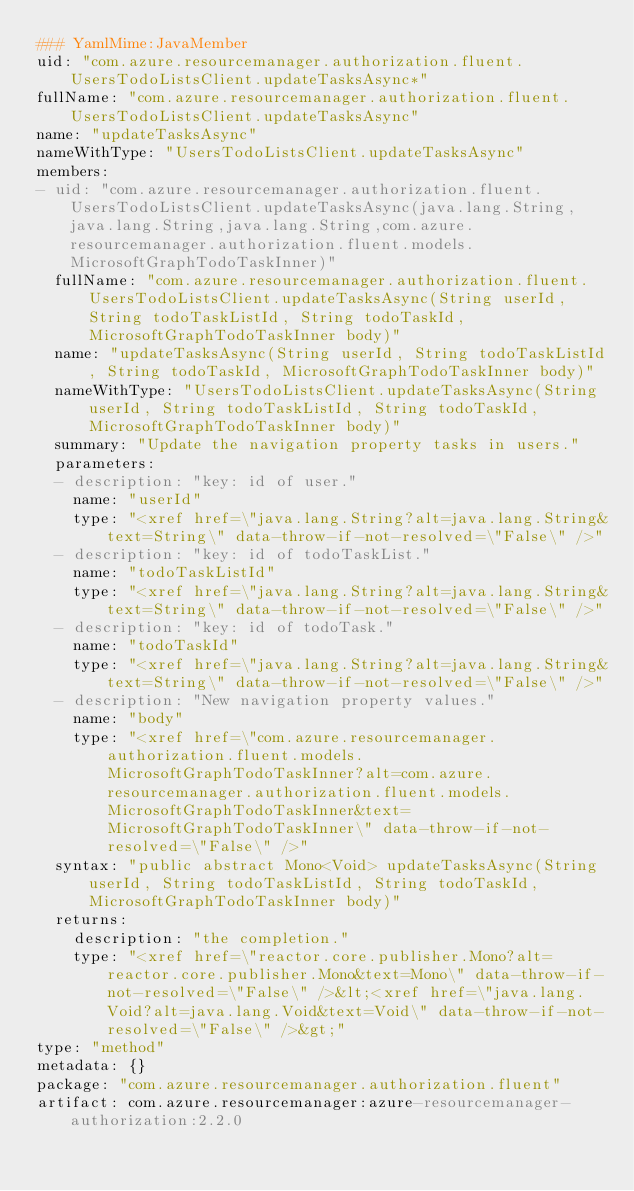<code> <loc_0><loc_0><loc_500><loc_500><_YAML_>### YamlMime:JavaMember
uid: "com.azure.resourcemanager.authorization.fluent.UsersTodoListsClient.updateTasksAsync*"
fullName: "com.azure.resourcemanager.authorization.fluent.UsersTodoListsClient.updateTasksAsync"
name: "updateTasksAsync"
nameWithType: "UsersTodoListsClient.updateTasksAsync"
members:
- uid: "com.azure.resourcemanager.authorization.fluent.UsersTodoListsClient.updateTasksAsync(java.lang.String,java.lang.String,java.lang.String,com.azure.resourcemanager.authorization.fluent.models.MicrosoftGraphTodoTaskInner)"
  fullName: "com.azure.resourcemanager.authorization.fluent.UsersTodoListsClient.updateTasksAsync(String userId, String todoTaskListId, String todoTaskId, MicrosoftGraphTodoTaskInner body)"
  name: "updateTasksAsync(String userId, String todoTaskListId, String todoTaskId, MicrosoftGraphTodoTaskInner body)"
  nameWithType: "UsersTodoListsClient.updateTasksAsync(String userId, String todoTaskListId, String todoTaskId, MicrosoftGraphTodoTaskInner body)"
  summary: "Update the navigation property tasks in users."
  parameters:
  - description: "key: id of user."
    name: "userId"
    type: "<xref href=\"java.lang.String?alt=java.lang.String&text=String\" data-throw-if-not-resolved=\"False\" />"
  - description: "key: id of todoTaskList."
    name: "todoTaskListId"
    type: "<xref href=\"java.lang.String?alt=java.lang.String&text=String\" data-throw-if-not-resolved=\"False\" />"
  - description: "key: id of todoTask."
    name: "todoTaskId"
    type: "<xref href=\"java.lang.String?alt=java.lang.String&text=String\" data-throw-if-not-resolved=\"False\" />"
  - description: "New navigation property values."
    name: "body"
    type: "<xref href=\"com.azure.resourcemanager.authorization.fluent.models.MicrosoftGraphTodoTaskInner?alt=com.azure.resourcemanager.authorization.fluent.models.MicrosoftGraphTodoTaskInner&text=MicrosoftGraphTodoTaskInner\" data-throw-if-not-resolved=\"False\" />"
  syntax: "public abstract Mono<Void> updateTasksAsync(String userId, String todoTaskListId, String todoTaskId, MicrosoftGraphTodoTaskInner body)"
  returns:
    description: "the completion."
    type: "<xref href=\"reactor.core.publisher.Mono?alt=reactor.core.publisher.Mono&text=Mono\" data-throw-if-not-resolved=\"False\" />&lt;<xref href=\"java.lang.Void?alt=java.lang.Void&text=Void\" data-throw-if-not-resolved=\"False\" />&gt;"
type: "method"
metadata: {}
package: "com.azure.resourcemanager.authorization.fluent"
artifact: com.azure.resourcemanager:azure-resourcemanager-authorization:2.2.0
</code> 